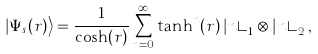<formula> <loc_0><loc_0><loc_500><loc_500>\left | \Psi _ { s } ( r ) \right > = \frac { 1 } { \cosh ( r ) } \sum _ { n = 0 } ^ { \infty } \tanh ^ { n } ( r ) \left | n \right > _ { 1 } \otimes \left | n \right > _ { 2 } ,</formula> 